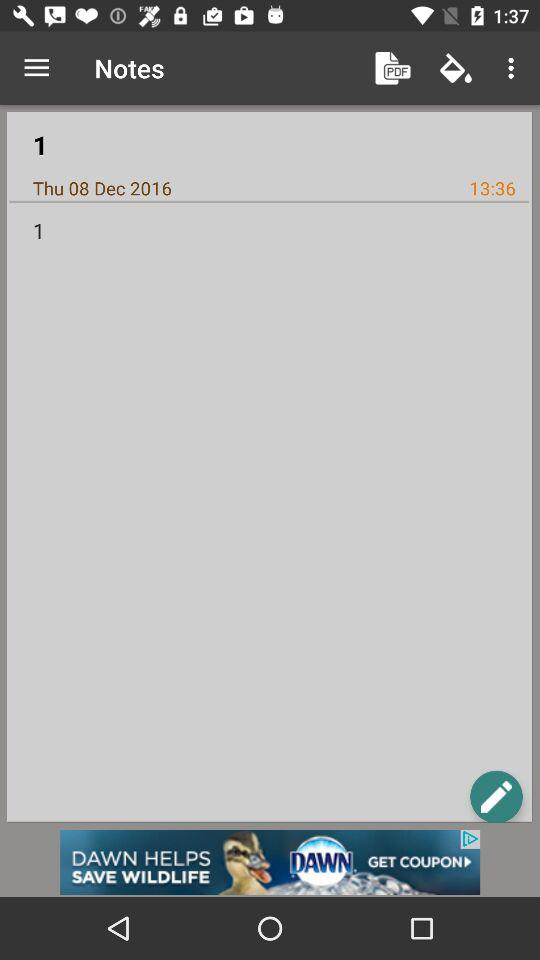On which date was the note saved? The note was saved on Thursday, December 8, 2016. 